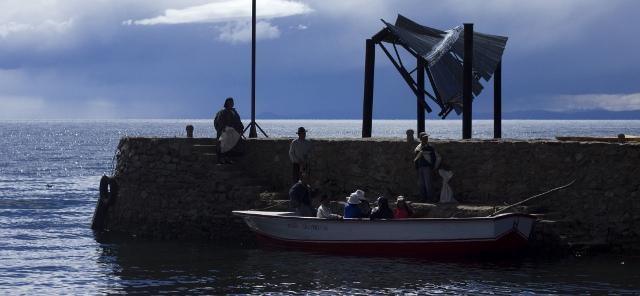How many boats are in the water?
Give a very brief answer. 1. How many giraffes are there in the grass?
Give a very brief answer. 0. 